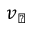<formula> <loc_0><loc_0><loc_500><loc_500>v _ { \perp }</formula> 